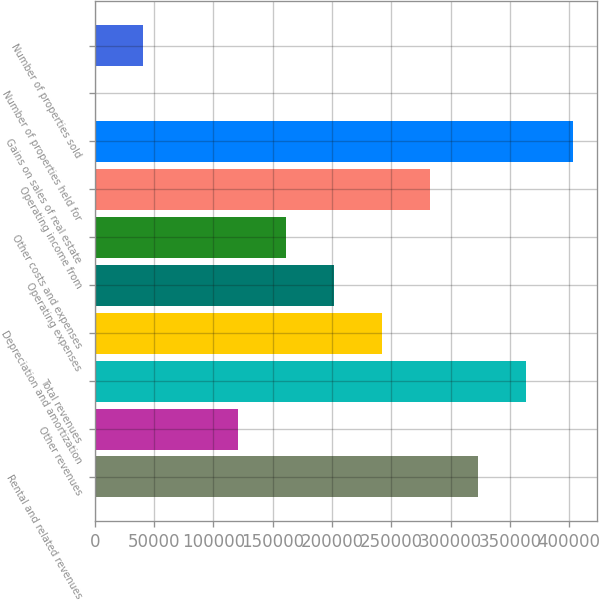Convert chart. <chart><loc_0><loc_0><loc_500><loc_500><bar_chart><fcel>Rental and related revenues<fcel>Other revenues<fcel>Total revenues<fcel>Depreciation and amortization<fcel>Operating expenses<fcel>Other costs and expenses<fcel>Operating income from<fcel>Gains on sales of real estate<fcel>Number of properties held for<fcel>Number of properties sold<nl><fcel>322879<fcel>121115<fcel>363231<fcel>242173<fcel>201820<fcel>161468<fcel>282526<fcel>403584<fcel>57<fcel>40409.7<nl></chart> 